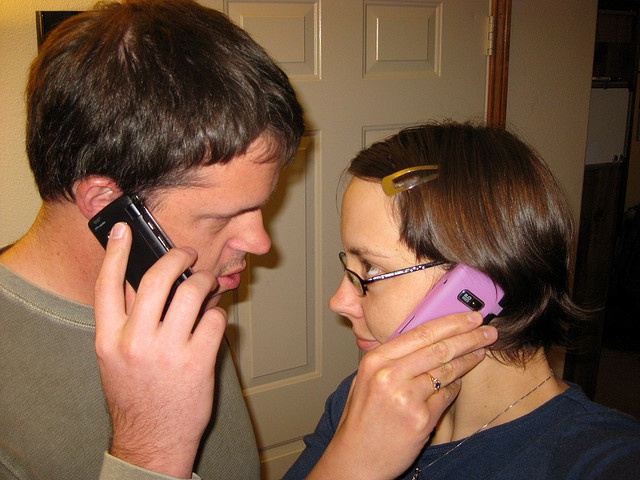Describe the objects in this image and their specific colors. I can see people in orange, black, gray, and salmon tones, people in orange, black, tan, and maroon tones, cell phone in orange, black, maroon, gray, and brown tones, and cell phone in orange, violet, and black tones in this image. 